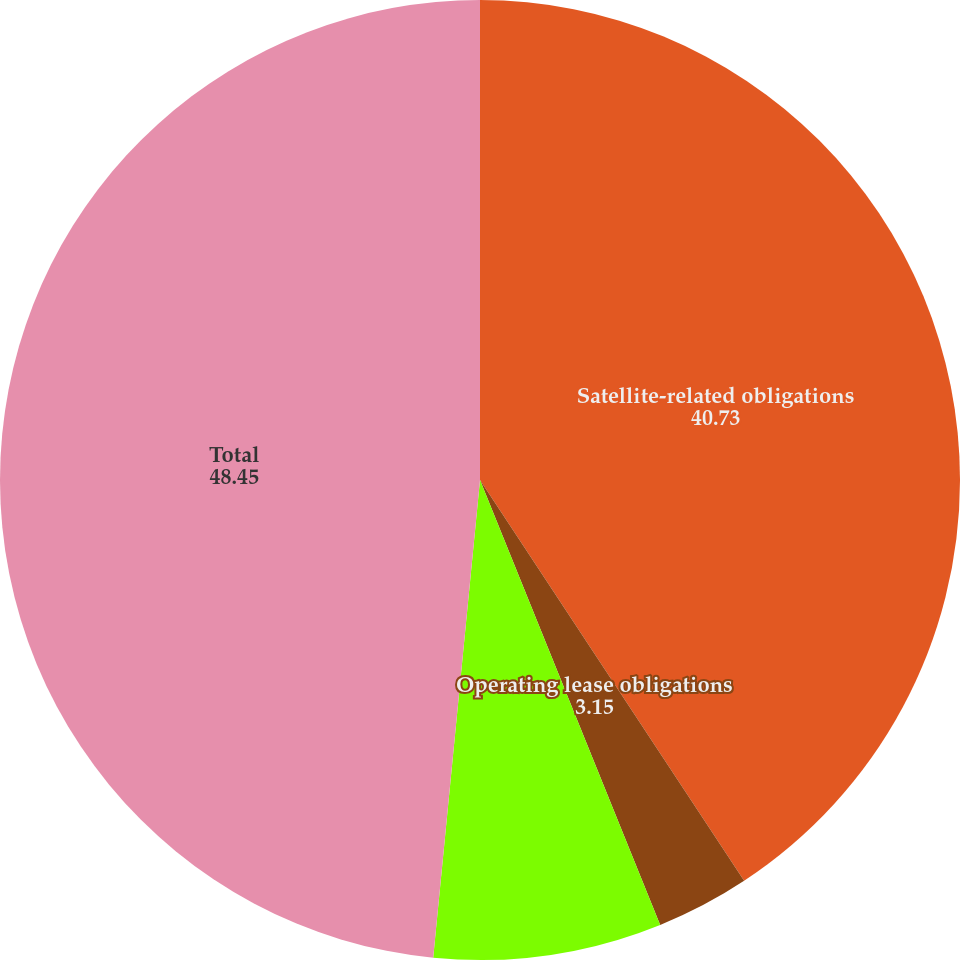<chart> <loc_0><loc_0><loc_500><loc_500><pie_chart><fcel>Satellite-related obligations<fcel>Operating lease obligations<fcel>Purchase obligations<fcel>Total<nl><fcel>40.73%<fcel>3.15%<fcel>7.68%<fcel>48.45%<nl></chart> 